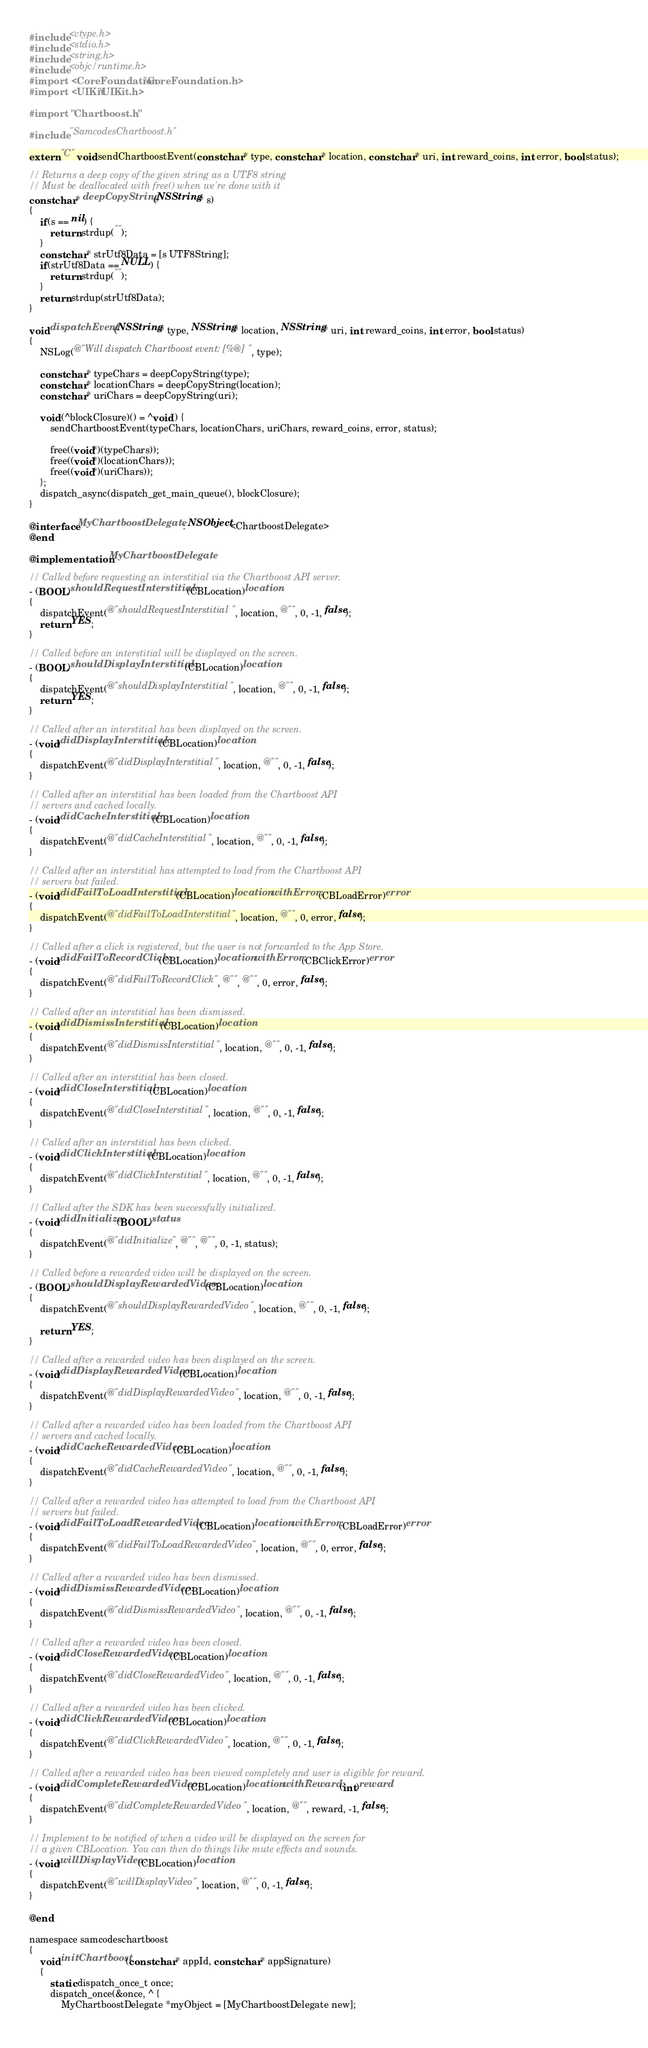<code> <loc_0><loc_0><loc_500><loc_500><_ObjectiveC_>#include <ctype.h>
#include <stdio.h>
#include <string.h>
#include <objc/runtime.h>
#import <CoreFoundation/CoreFoundation.h>
#import <UIKit/UIKit.h>

#import "Chartboost.h"

#include "SamcodesChartboost.h"

extern "C" void sendChartboostEvent(const char* type, const char* location, const char* uri, int reward_coins, int error, bool status);

// Returns a deep copy of the given string as a UTF8 string
// Must be deallocated with free() when we're done with it
const char* deepCopyString(NSString* s)
{
    if(s == nil) {
        return strdup("");
    }
    const char* strUtf8Data = [s UTF8String];
    if(strUtf8Data == NULL) {
        return strdup("");
    }
    return strdup(strUtf8Data);
}

void dispatchEvent(NSString* type, NSString* location, NSString* uri, int reward_coins, int error, bool status)
{
    NSLog(@"Will dispatch Chartboost event: [%@]", type);
    
    const char* typeChars = deepCopyString(type);
    const char* locationChars = deepCopyString(location);
    const char* uriChars = deepCopyString(uri);

    void (^blockClosure)() = ^void() {
        sendChartboostEvent(typeChars, locationChars, uriChars, reward_coins, error, status);
        
        free((void*)(typeChars));
        free((void*)(locationChars));
        free((void*)(uriChars));
    };
    dispatch_async(dispatch_get_main_queue(), blockClosure);
}

@interface MyChartboostDelegate : NSObject<ChartboostDelegate>
@end

@implementation MyChartboostDelegate

// Called before requesting an interstitial via the Chartboost API server.
- (BOOL)shouldRequestInterstitial:(CBLocation)location
{
    dispatchEvent(@"shouldRequestInterstitial", location, @"", 0, -1, false);
    return YES;
}

// Called before an interstitial will be displayed on the screen.
- (BOOL)shouldDisplayInterstitial:(CBLocation)location
{
    dispatchEvent(@"shouldDisplayInterstitial", location, @"", 0, -1, false);
    return YES;
}

// Called after an interstitial has been displayed on the screen.
- (void)didDisplayInterstitial:(CBLocation)location
{
    dispatchEvent(@"didDisplayInterstitial", location, @"", 0, -1, false);
}

// Called after an interstitial has been loaded from the Chartboost API
// servers and cached locally.
- (void)didCacheInterstitial:(CBLocation)location
{
    dispatchEvent(@"didCacheInterstitial", location, @"", 0, -1, false);
}

// Called after an interstitial has attempted to load from the Chartboost API
// servers but failed.
- (void)didFailToLoadInterstitial:(CBLocation)location withError:(CBLoadError)error
{
    dispatchEvent(@"didFailToLoadInterstitial", location, @"", 0, error, false);
}

// Called after a click is registered, but the user is not forwarded to the App Store.
- (void)didFailToRecordClick:(CBLocation)location withError:(CBClickError)error
{
    dispatchEvent(@"didFailToRecordClick", @"", @"", 0, error, false);
}

// Called after an interstitial has been dismissed.
- (void)didDismissInterstitial:(CBLocation)location
{
    dispatchEvent(@"didDismissInterstitial", location, @"", 0, -1, false);
}

// Called after an interstitial has been closed.
- (void)didCloseInterstitial:(CBLocation)location
{
    dispatchEvent(@"didCloseInterstitial", location, @"", 0, -1, false);
}

// Called after an interstitial has been clicked.
- (void)didClickInterstitial:(CBLocation)location
{
    dispatchEvent(@"didClickInterstitial", location, @"", 0, -1, false);
}

// Called after the SDK has been successfully initialized.
- (void)didInitialize:(BOOL)status
{
    dispatchEvent(@"didInitialize", @"", @"", 0, -1, status);
}

// Called before a rewarded video will be displayed on the screen.
- (BOOL)shouldDisplayRewardedVideo:(CBLocation)location
{
    dispatchEvent(@"shouldDisplayRewardedVideo", location, @"", 0, -1, false);
    
    return YES;
}

// Called after a rewarded video has been displayed on the screen.
- (void)didDisplayRewardedVideo:(CBLocation)location
{
    dispatchEvent(@"didDisplayRewardedVideo", location, @"", 0, -1, false);
}

// Called after a rewarded video has been loaded from the Chartboost API
// servers and cached locally.
- (void)didCacheRewardedVideo:(CBLocation)location
{
    dispatchEvent(@"didCacheRewardedVideo", location, @"", 0, -1, false);
}

// Called after a rewarded video has attempted to load from the Chartboost API
// servers but failed.
- (void)didFailToLoadRewardedVideo:(CBLocation)location withError:(CBLoadError)error
{
    dispatchEvent(@"didFailToLoadRewardedVideo", location, @"", 0, error, false);
}

// Called after a rewarded video has been dismissed.
- (void)didDismissRewardedVideo:(CBLocation)location
{
    dispatchEvent(@"didDismissRewardedVideo", location, @"", 0, -1, false);
}

// Called after a rewarded video has been closed.
- (void)didCloseRewardedVideo:(CBLocation)location
{
    dispatchEvent(@"didCloseRewardedVideo", location, @"", 0, -1, false);
}

// Called after a rewarded video has been clicked.
- (void)didClickRewardedVideo:(CBLocation)location
{
    dispatchEvent(@"didClickRewardedVideo", location, @"", 0, -1, false);
}

// Called after a rewarded video has been viewed completely and user is eligible for reward.
- (void)didCompleteRewardedVideo:(CBLocation)location withReward:(int)reward
{
    dispatchEvent(@"didCompleteRewardedVideo", location, @"", reward, -1, false);
}

// Implement to be notified of when a video will be displayed on the screen for
// a given CBLocation. You can then do things like mute effects and sounds.
- (void)willDisplayVideo:(CBLocation)location
{
    dispatchEvent(@"willDisplayVideo", location, @"", 0, -1, false);
}

@end

namespace samcodeschartboost
{
    void initChartboost(const char* appId, const char* appSignature)
    {
        static dispatch_once_t once;
        dispatch_once(&once, ^ {
            MyChartboostDelegate *myObject = [MyChartboostDelegate new];
            </code> 